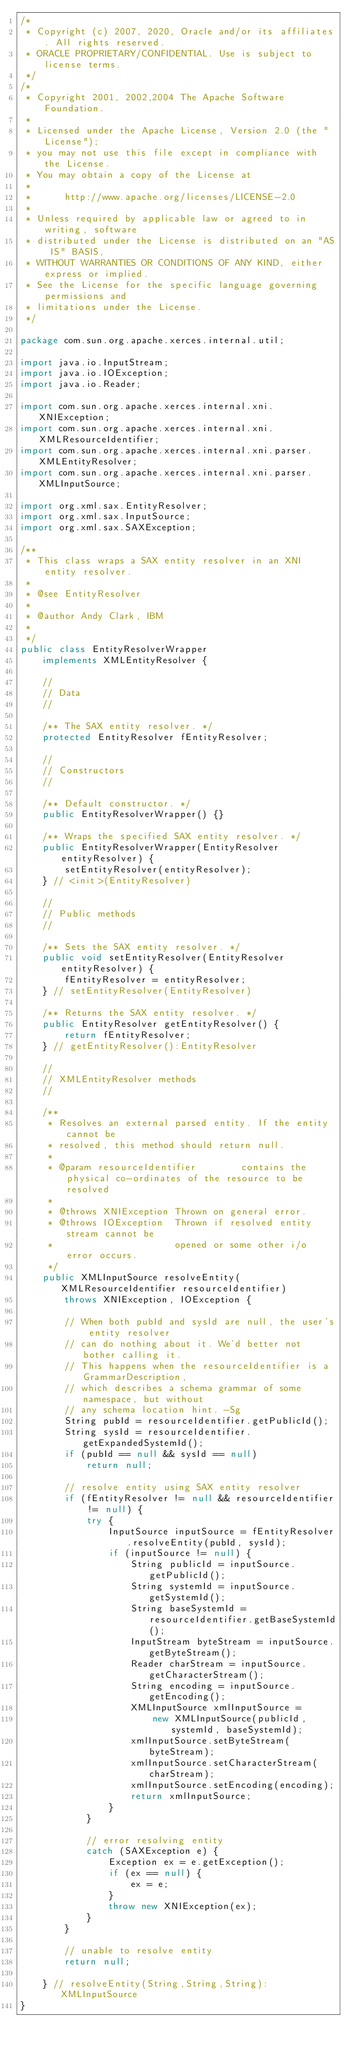Convert code to text. <code><loc_0><loc_0><loc_500><loc_500><_Java_>/*
 * Copyright (c) 2007, 2020, Oracle and/or its affiliates. All rights reserved.
 * ORACLE PROPRIETARY/CONFIDENTIAL. Use is subject to license terms.
 */
/*
 * Copyright 2001, 2002,2004 The Apache Software Foundation.
 *
 * Licensed under the Apache License, Version 2.0 (the "License");
 * you may not use this file except in compliance with the License.
 * You may obtain a copy of the License at
 *
 *      http://www.apache.org/licenses/LICENSE-2.0
 *
 * Unless required by applicable law or agreed to in writing, software
 * distributed under the License is distributed on an "AS IS" BASIS,
 * WITHOUT WARRANTIES OR CONDITIONS OF ANY KIND, either express or implied.
 * See the License for the specific language governing permissions and
 * limitations under the License.
 */

package com.sun.org.apache.xerces.internal.util;

import java.io.InputStream;
import java.io.IOException;
import java.io.Reader;

import com.sun.org.apache.xerces.internal.xni.XNIException;
import com.sun.org.apache.xerces.internal.xni.XMLResourceIdentifier;
import com.sun.org.apache.xerces.internal.xni.parser.XMLEntityResolver;
import com.sun.org.apache.xerces.internal.xni.parser.XMLInputSource;

import org.xml.sax.EntityResolver;
import org.xml.sax.InputSource;
import org.xml.sax.SAXException;

/**
 * This class wraps a SAX entity resolver in an XNI entity resolver.
 *
 * @see EntityResolver
 *
 * @author Andy Clark, IBM
 *
 */
public class EntityResolverWrapper
    implements XMLEntityResolver {

    //
    // Data
    //

    /** The SAX entity resolver. */
    protected EntityResolver fEntityResolver;

    //
    // Constructors
    //

    /** Default constructor. */
    public EntityResolverWrapper() {}

    /** Wraps the specified SAX entity resolver. */
    public EntityResolverWrapper(EntityResolver entityResolver) {
        setEntityResolver(entityResolver);
    } // <init>(EntityResolver)

    //
    // Public methods
    //

    /** Sets the SAX entity resolver. */
    public void setEntityResolver(EntityResolver entityResolver) {
        fEntityResolver = entityResolver;
    } // setEntityResolver(EntityResolver)

    /** Returns the SAX entity resolver. */
    public EntityResolver getEntityResolver() {
        return fEntityResolver;
    } // getEntityResolver():EntityResolver

    //
    // XMLEntityResolver methods
    //

    /**
     * Resolves an external parsed entity. If the entity cannot be
     * resolved, this method should return null.
     *
     * @param resourceIdentifier        contains the physical co-ordinates of the resource to be resolved
     *
     * @throws XNIException Thrown on general error.
     * @throws IOException  Thrown if resolved entity stream cannot be
     *                      opened or some other i/o error occurs.
     */
    public XMLInputSource resolveEntity(XMLResourceIdentifier resourceIdentifier)
        throws XNIException, IOException {

        // When both pubId and sysId are null, the user's entity resolver
        // can do nothing about it. We'd better not bother calling it.
        // This happens when the resourceIdentifier is a GrammarDescription,
        // which describes a schema grammar of some namespace, but without
        // any schema location hint. -Sg
        String pubId = resourceIdentifier.getPublicId();
        String sysId = resourceIdentifier.getExpandedSystemId();
        if (pubId == null && sysId == null)
            return null;

        // resolve entity using SAX entity resolver
        if (fEntityResolver != null && resourceIdentifier != null) {
            try {
                InputSource inputSource = fEntityResolver.resolveEntity(pubId, sysId);
                if (inputSource != null) {
                    String publicId = inputSource.getPublicId();
                    String systemId = inputSource.getSystemId();
                    String baseSystemId = resourceIdentifier.getBaseSystemId();
                    InputStream byteStream = inputSource.getByteStream();
                    Reader charStream = inputSource.getCharacterStream();
                    String encoding = inputSource.getEncoding();
                    XMLInputSource xmlInputSource =
                        new XMLInputSource(publicId, systemId, baseSystemId);
                    xmlInputSource.setByteStream(byteStream);
                    xmlInputSource.setCharacterStream(charStream);
                    xmlInputSource.setEncoding(encoding);
                    return xmlInputSource;
                }
            }

            // error resolving entity
            catch (SAXException e) {
                Exception ex = e.getException();
                if (ex == null) {
                    ex = e;
                }
                throw new XNIException(ex);
            }
        }

        // unable to resolve entity
        return null;

    } // resolveEntity(String,String,String):XMLInputSource
}
</code> 